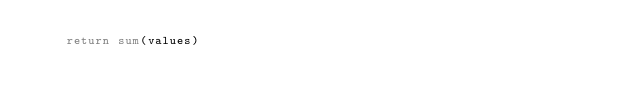<code> <loc_0><loc_0><loc_500><loc_500><_Python_>    return sum(values)
</code> 